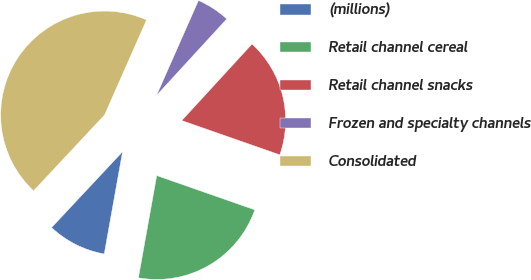Convert chart to OTSL. <chart><loc_0><loc_0><loc_500><loc_500><pie_chart><fcel>(millions)<fcel>Retail channel cereal<fcel>Retail channel snacks<fcel>Frozen and specialty channels<fcel>Consolidated<nl><fcel>9.15%<fcel>22.47%<fcel>18.53%<fcel>5.2%<fcel>44.65%<nl></chart> 